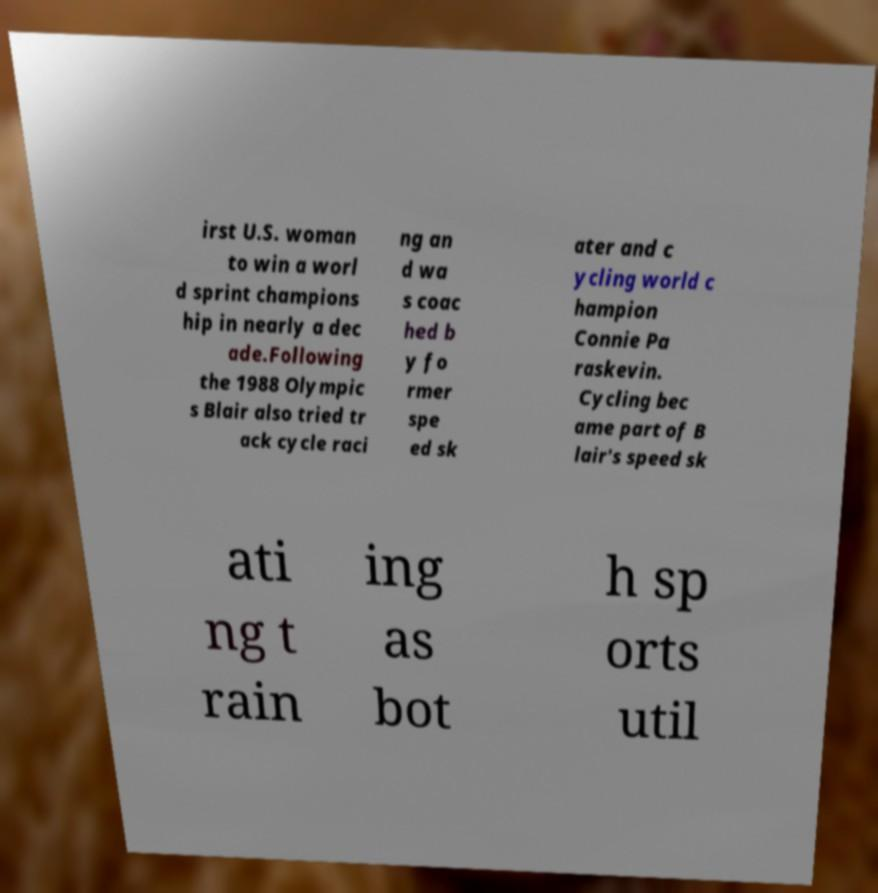Can you accurately transcribe the text from the provided image for me? irst U.S. woman to win a worl d sprint champions hip in nearly a dec ade.Following the 1988 Olympic s Blair also tried tr ack cycle raci ng an d wa s coac hed b y fo rmer spe ed sk ater and c ycling world c hampion Connie Pa raskevin. Cycling bec ame part of B lair's speed sk ati ng t rain ing as bot h sp orts util 